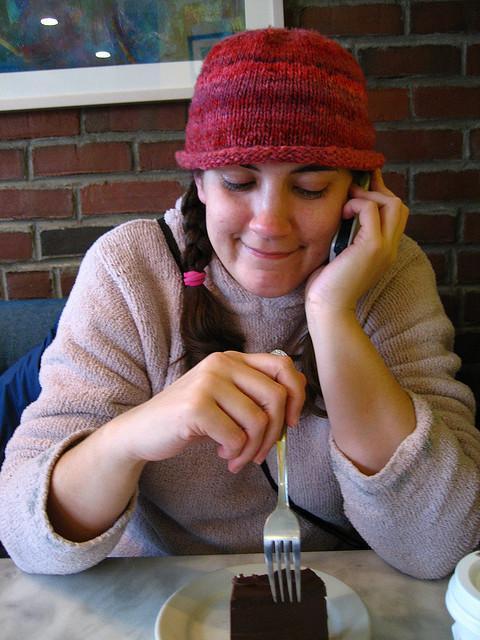How many cups are there?
Give a very brief answer. 1. 